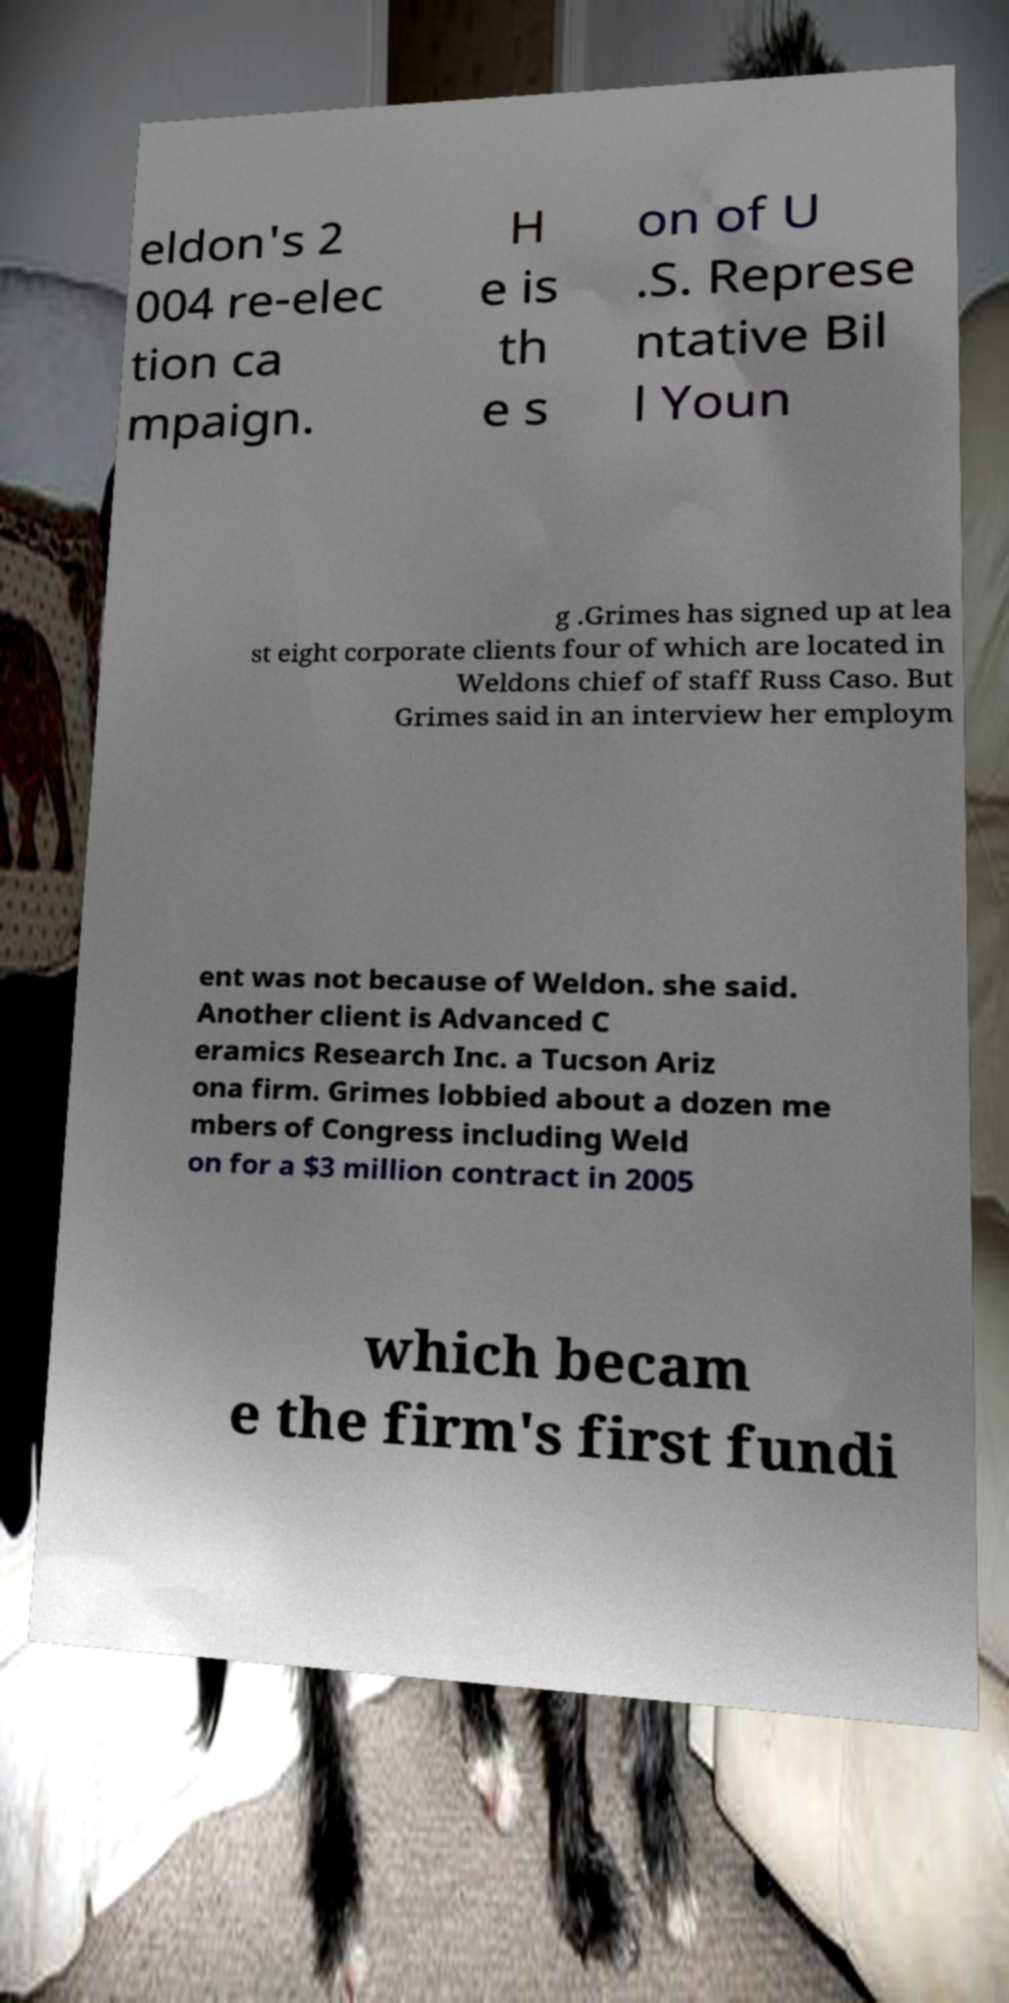Please identify and transcribe the text found in this image. eldon's 2 004 re-elec tion ca mpaign. H e is th e s on of U .S. Represe ntative Bil l Youn g .Grimes has signed up at lea st eight corporate clients four of which are located in Weldons chief of staff Russ Caso. But Grimes said in an interview her employm ent was not because of Weldon. she said. Another client is Advanced C eramics Research Inc. a Tucson Ariz ona firm. Grimes lobbied about a dozen me mbers of Congress including Weld on for a $3 million contract in 2005 which becam e the firm's first fundi 